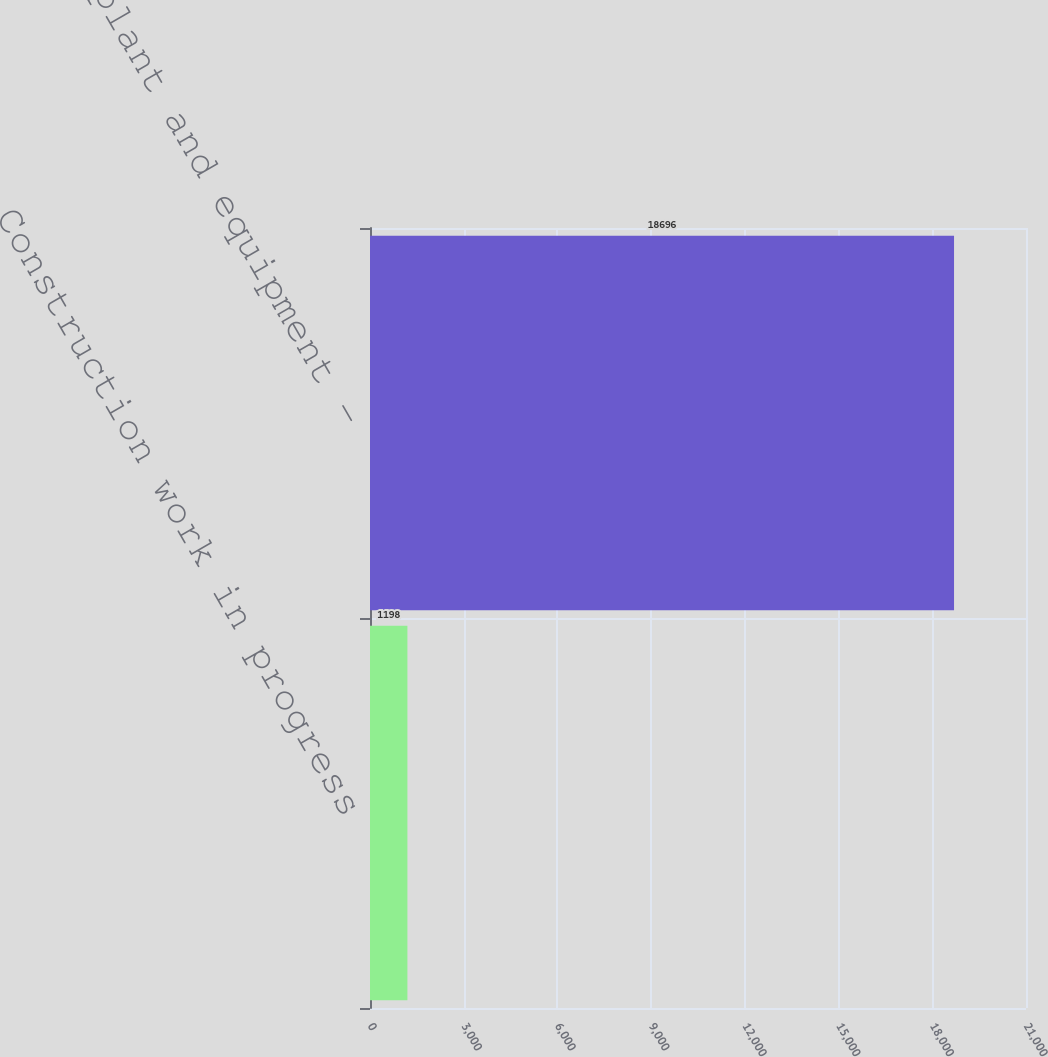<chart> <loc_0><loc_0><loc_500><loc_500><bar_chart><fcel>Construction work in progress<fcel>Property plant and equipment -<nl><fcel>1198<fcel>18696<nl></chart> 